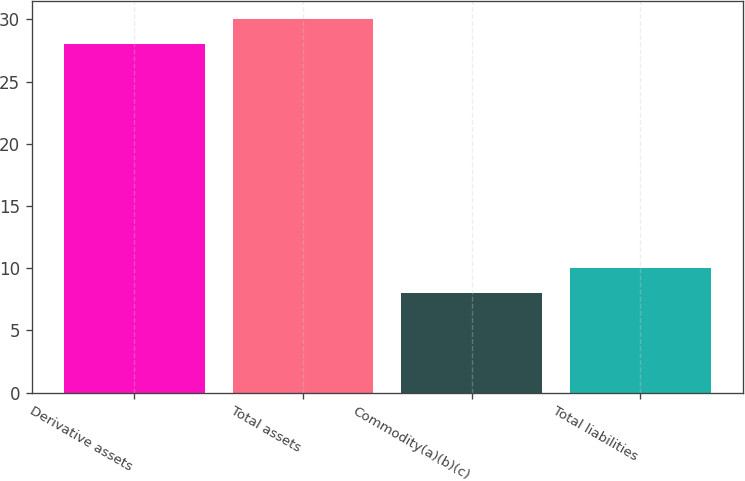Convert chart to OTSL. <chart><loc_0><loc_0><loc_500><loc_500><bar_chart><fcel>Derivative assets<fcel>Total assets<fcel>Commodity(a)(b)(c)<fcel>Total liabilities<nl><fcel>28<fcel>30<fcel>8<fcel>10<nl></chart> 